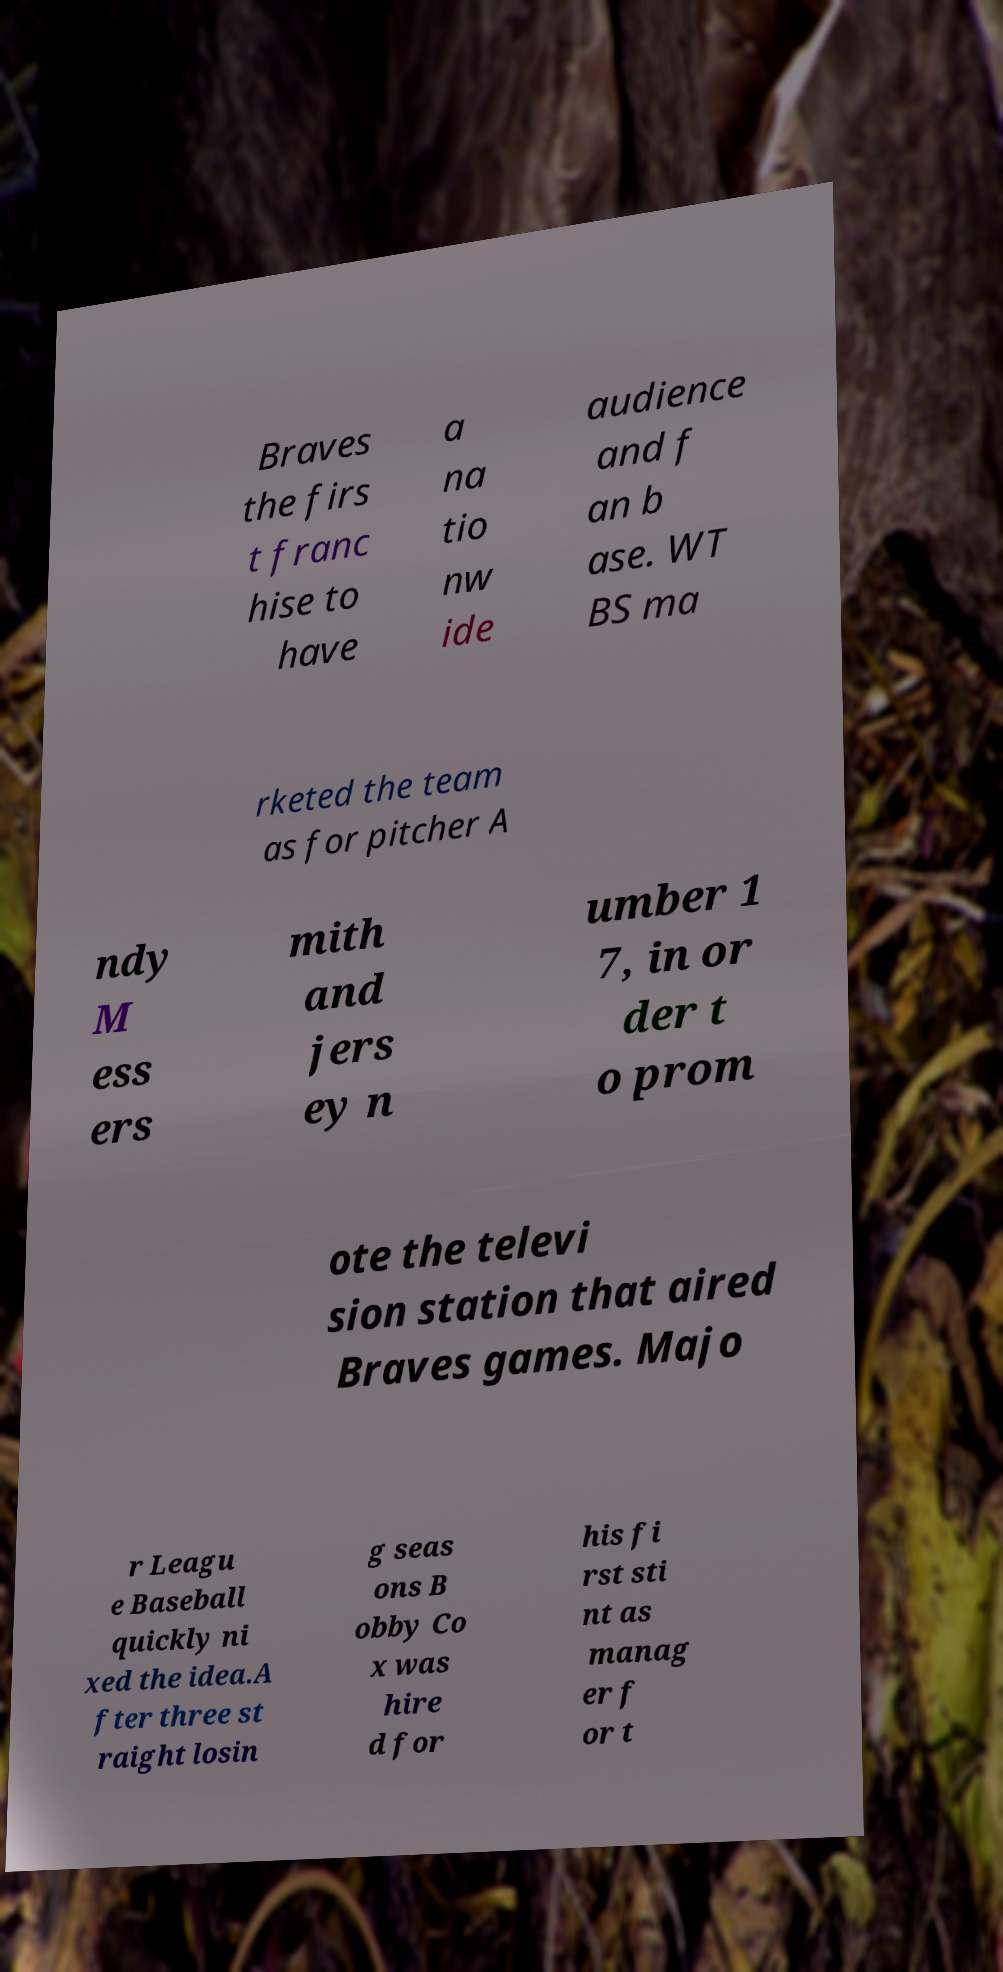There's text embedded in this image that I need extracted. Can you transcribe it verbatim? Braves the firs t franc hise to have a na tio nw ide audience and f an b ase. WT BS ma rketed the team as for pitcher A ndy M ess ers mith and jers ey n umber 1 7, in or der t o prom ote the televi sion station that aired Braves games. Majo r Leagu e Baseball quickly ni xed the idea.A fter three st raight losin g seas ons B obby Co x was hire d for his fi rst sti nt as manag er f or t 